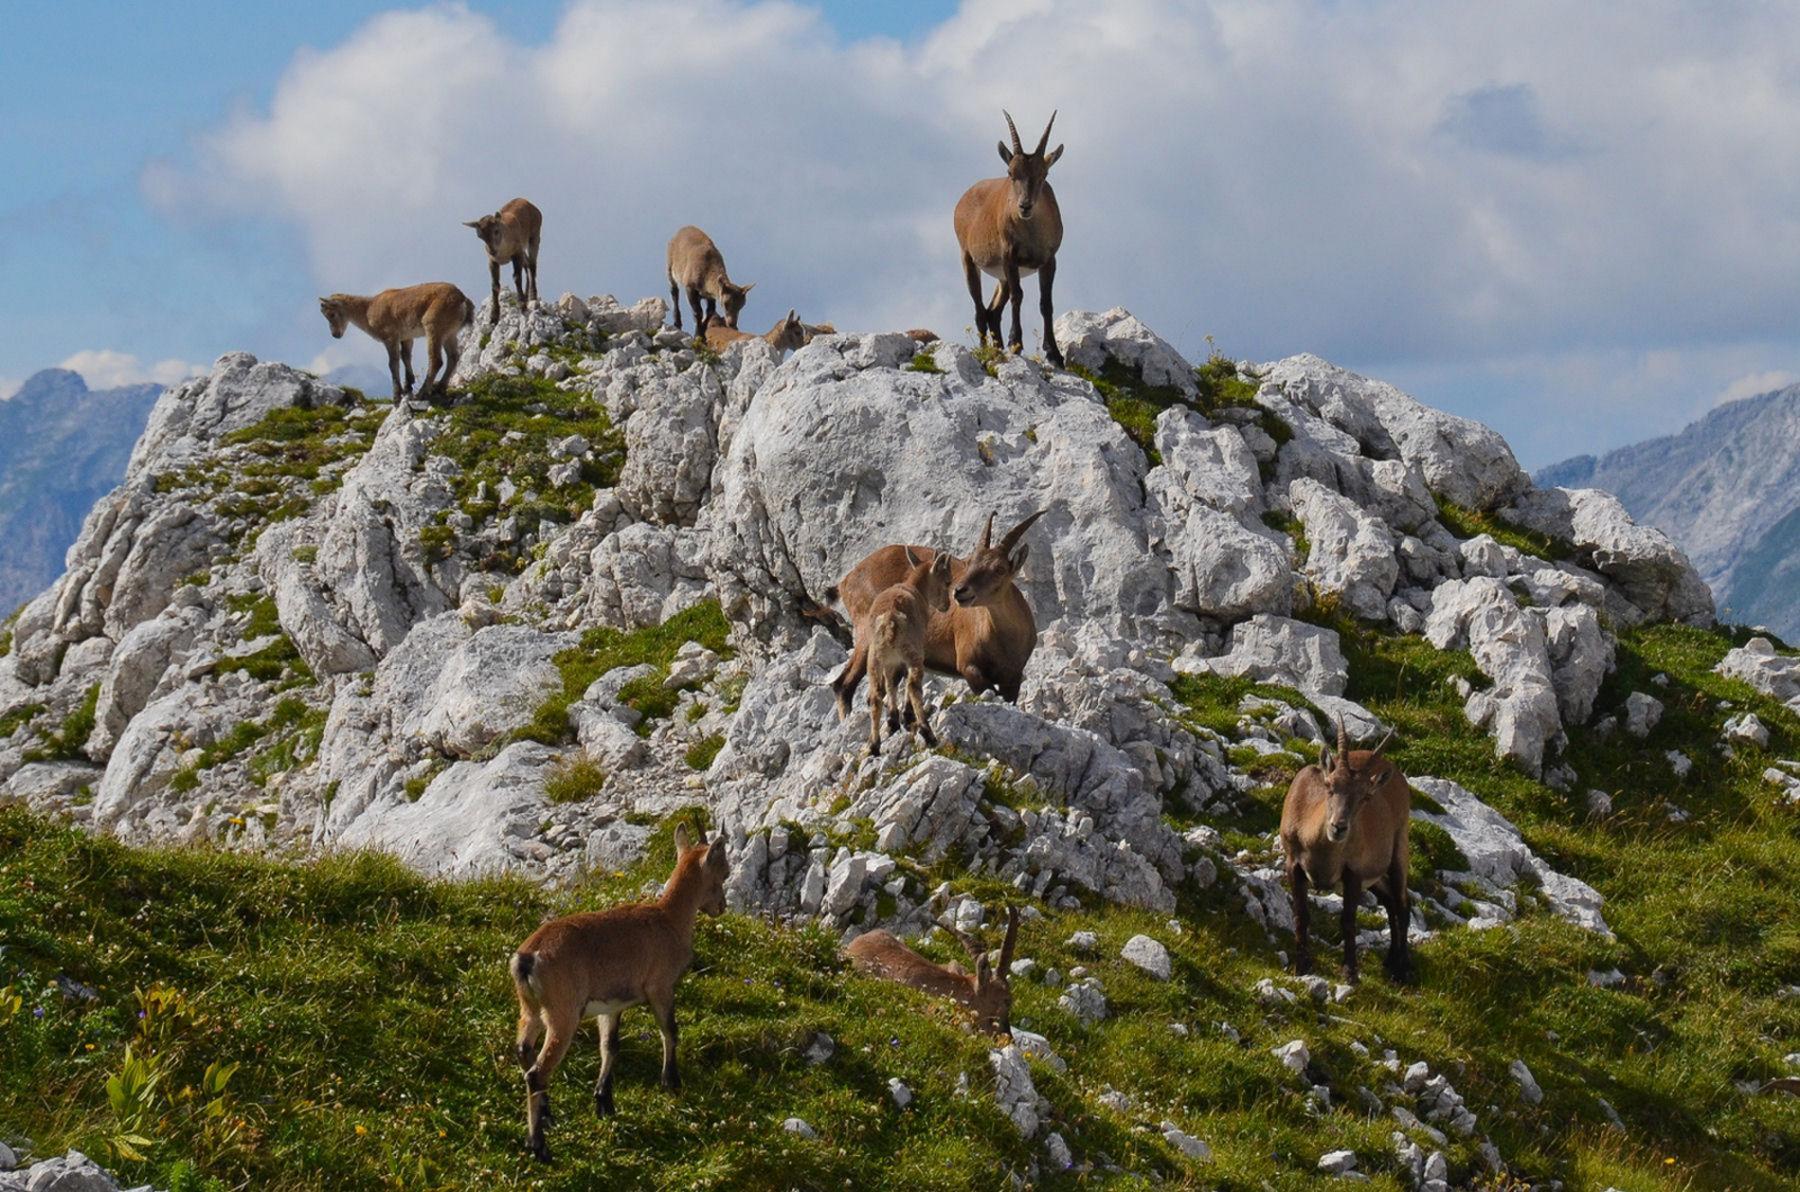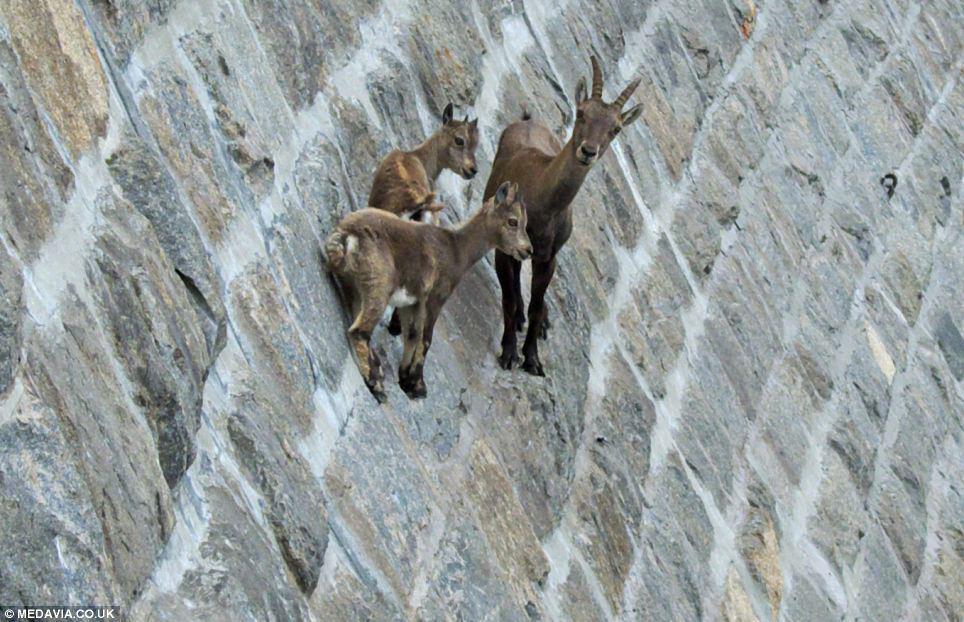The first image is the image on the left, the second image is the image on the right. Considering the images on both sides, is "An image shows a single horned animal in a non-standing position." valid? Answer yes or no. No. The first image is the image on the left, the second image is the image on the right. Analyze the images presented: Is the assertion "A single horned animal is in a grassy area in one of the images." valid? Answer yes or no. No. 